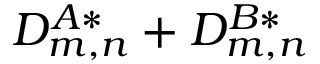<formula> <loc_0><loc_0><loc_500><loc_500>D _ { m , n } ^ { A * } + D _ { m , n } ^ { B * }</formula> 